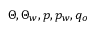<formula> <loc_0><loc_0><loc_500><loc_500>\Theta , \Theta _ { w } , p , p _ { w } , q _ { o }</formula> 